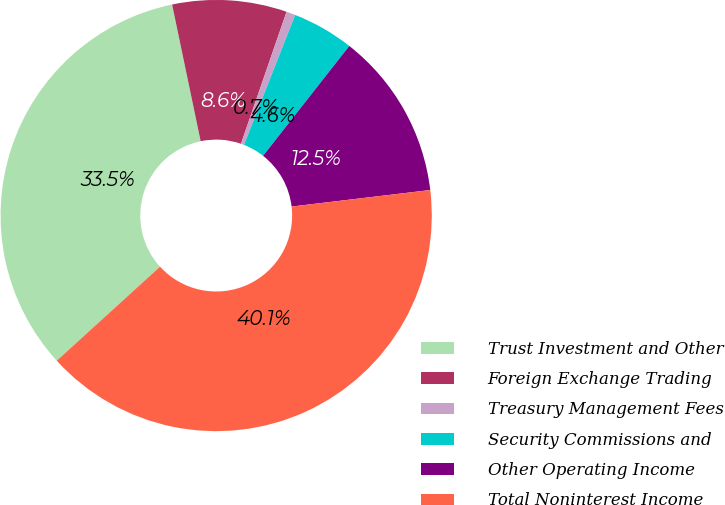Convert chart to OTSL. <chart><loc_0><loc_0><loc_500><loc_500><pie_chart><fcel>Trust Investment and Other<fcel>Foreign Exchange Trading<fcel>Treasury Management Fees<fcel>Security Commissions and<fcel>Other Operating Income<fcel>Total Noninterest Income<nl><fcel>33.48%<fcel>8.57%<fcel>0.68%<fcel>4.62%<fcel>12.52%<fcel>40.14%<nl></chart> 